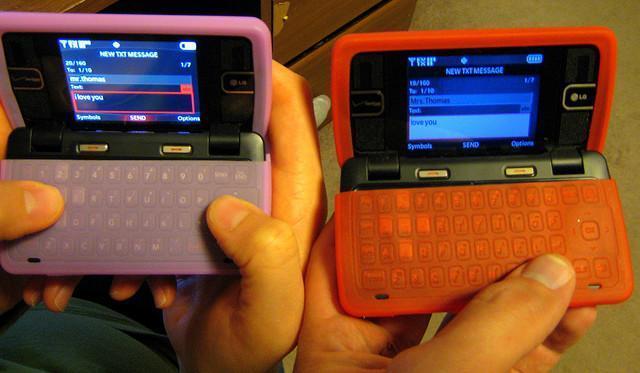How many cell phones are visible?
Give a very brief answer. 2. How many people are there?
Give a very brief answer. 2. How many horses are in the stables?
Give a very brief answer. 0. 